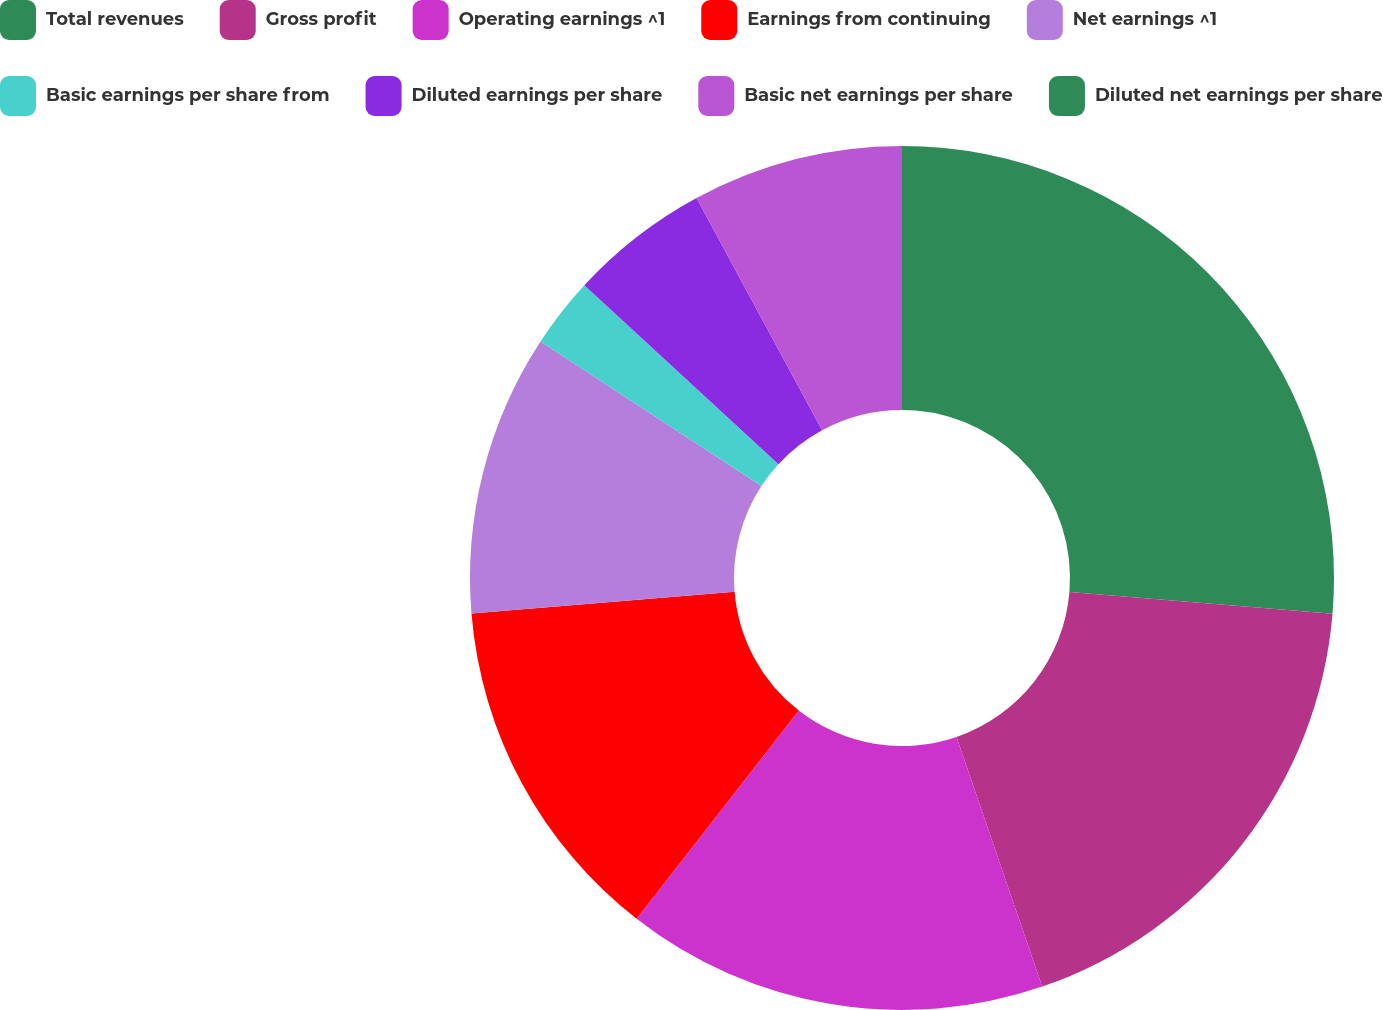Convert chart to OTSL. <chart><loc_0><loc_0><loc_500><loc_500><pie_chart><fcel>Total revenues<fcel>Gross profit<fcel>Operating earnings ^1<fcel>Earnings from continuing<fcel>Net earnings ^1<fcel>Basic earnings per share from<fcel>Diluted earnings per share<fcel>Basic net earnings per share<fcel>Diluted net earnings per share<nl><fcel>26.32%<fcel>18.42%<fcel>15.79%<fcel>13.16%<fcel>10.53%<fcel>2.63%<fcel>5.26%<fcel>7.89%<fcel>0.0%<nl></chart> 